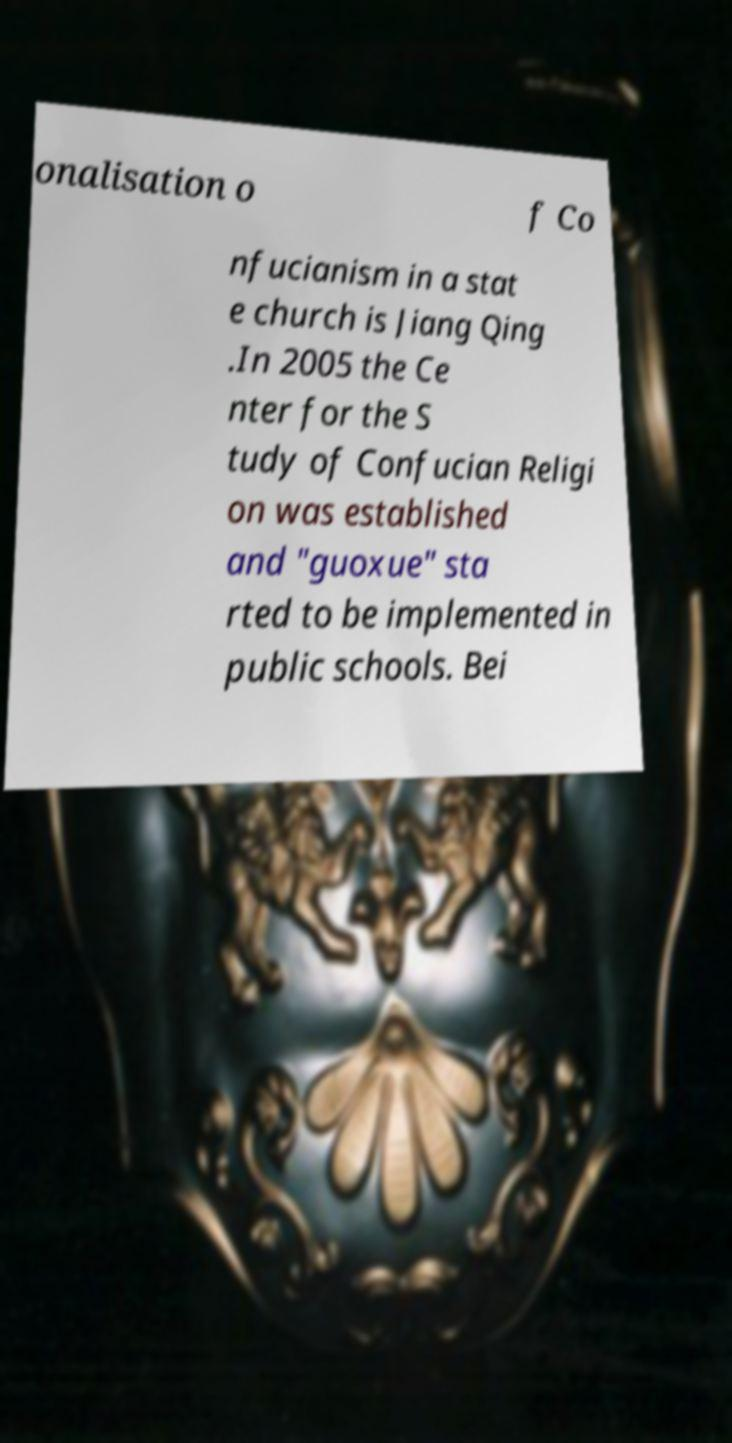I need the written content from this picture converted into text. Can you do that? onalisation o f Co nfucianism in a stat e church is Jiang Qing .In 2005 the Ce nter for the S tudy of Confucian Religi on was established and "guoxue" sta rted to be implemented in public schools. Bei 